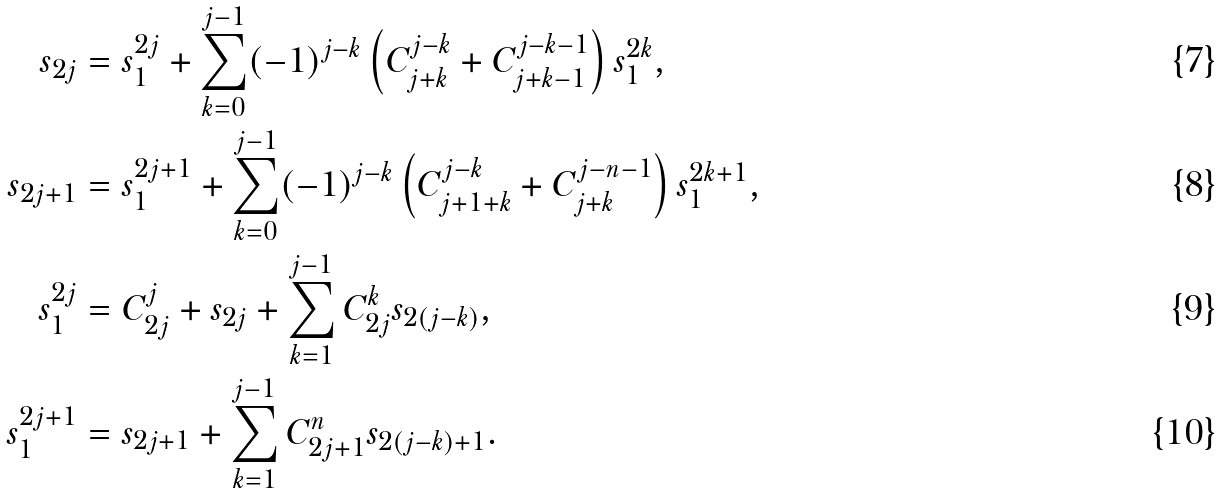<formula> <loc_0><loc_0><loc_500><loc_500>s _ { 2 j } & = s _ { 1 } ^ { 2 j } + \sum _ { k = 0 } ^ { j - 1 } ( - 1 ) ^ { j - k } \left ( C _ { j + k } ^ { j - k } + C _ { j + k - 1 } ^ { j - k - 1 } \right ) s _ { 1 } ^ { 2 k } , \\ s _ { 2 j + 1 } & = s _ { 1 } ^ { 2 j + 1 } + \sum _ { k = 0 } ^ { j - 1 } ( - 1 ) ^ { j - k } \left ( C _ { j + 1 + k } ^ { j - k } + C _ { j + k } ^ { j - n - 1 } \right ) s _ { 1 } ^ { 2 k + 1 } , \\ s _ { 1 } ^ { 2 j } & = C _ { 2 j } ^ { j } + s _ { 2 j } + \sum _ { k = 1 } ^ { j - 1 } C _ { 2 j } ^ { k } s _ { 2 ( j - k ) } , \\ s _ { 1 } ^ { 2 j + 1 } & = s _ { 2 j + 1 } + \sum _ { k = 1 } ^ { j - 1 } C _ { 2 j + 1 } ^ { n } s _ { 2 ( j - k ) + 1 } .</formula> 